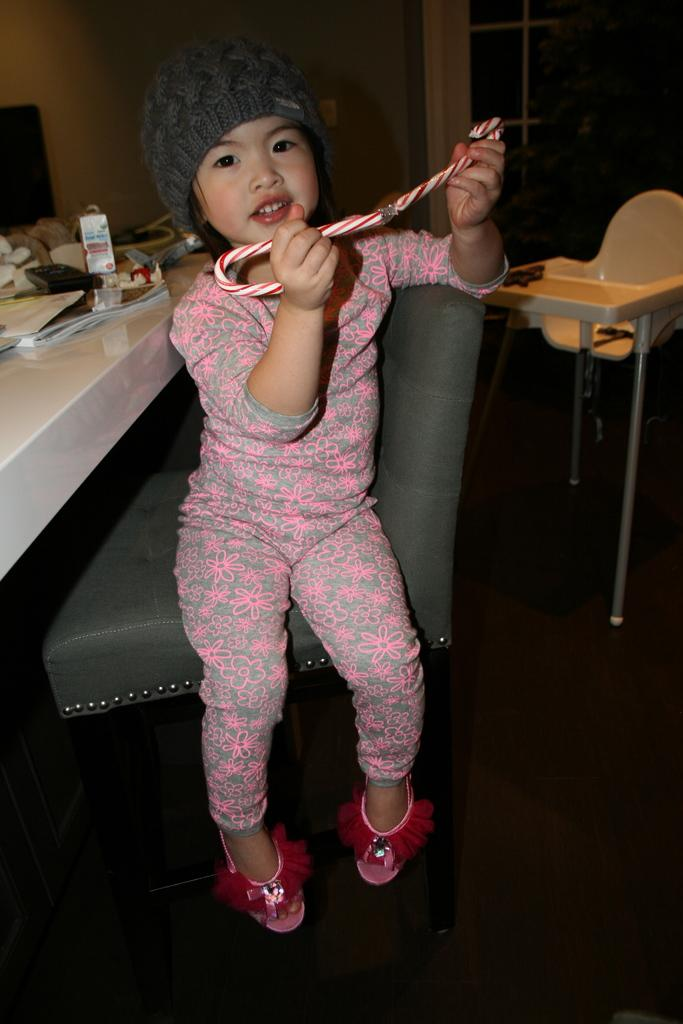What is the main subject of the image? The main subject of the image is a small kid. What is the kid doing in the image? The kid is sitting on a chair. What is the kid holding in the image? The kid is holding a white and red straw. What can be seen in the background of the image? There are tables, chairs, and a glass window in the background of the image. What type of slave is depicted in the image? There is no depiction of a slave in the image; it features a small kid sitting on a chair and holding a white and red straw. 